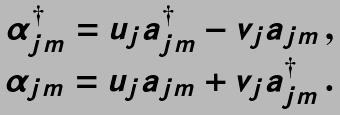<formula> <loc_0><loc_0><loc_500><loc_500>\begin{array} { c } \alpha ^ { \dagger } _ { j m } = u _ { j } a ^ { \dagger } _ { j m } - v _ { j } a _ { j m } \, , \\ \alpha _ { j m } = u _ { j } a _ { j m } + v _ { j } a ^ { \dagger } _ { j m } \, . \end{array}</formula> 